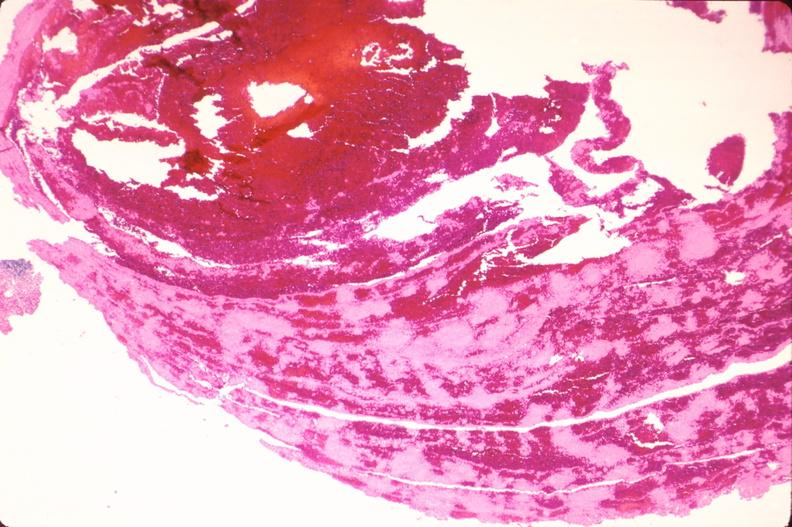s vasculature present?
Answer the question using a single word or phrase. Yes 